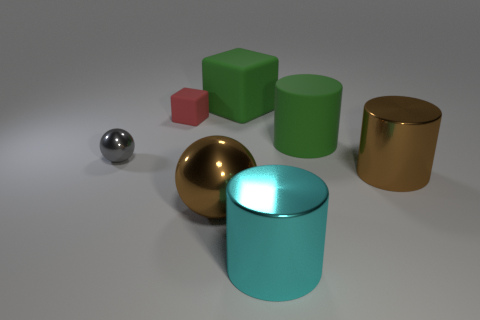Add 1 gray objects. How many objects exist? 8 Subtract all spheres. How many objects are left? 5 Subtract all red matte objects. Subtract all shiny spheres. How many objects are left? 4 Add 4 tiny metallic balls. How many tiny metallic balls are left? 5 Add 5 large cyan shiny cylinders. How many large cyan shiny cylinders exist? 6 Subtract 0 brown cubes. How many objects are left? 7 